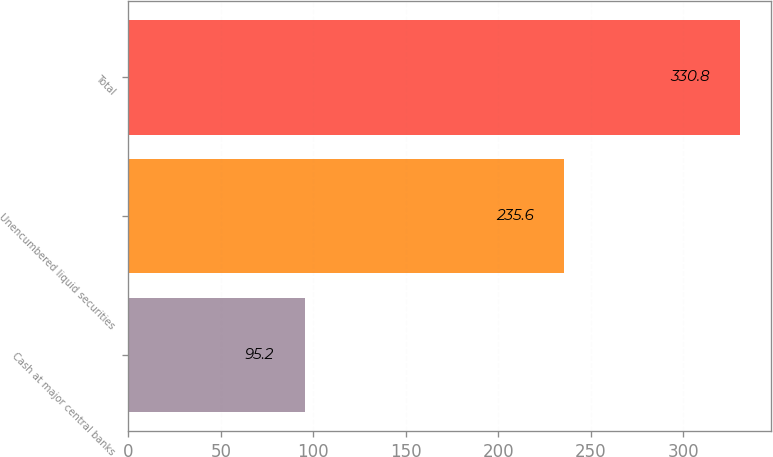Convert chart. <chart><loc_0><loc_0><loc_500><loc_500><bar_chart><fcel>Cash at major central banks<fcel>Unencumbered liquid securities<fcel>Total<nl><fcel>95.2<fcel>235.6<fcel>330.8<nl></chart> 